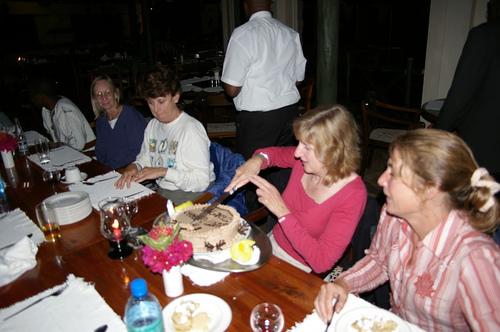What age group are these people in?
Concise answer only. 40s. How many people are at each table?
Answer briefly. 5. What color is the writing on the cake?
Quick response, please. Brown. What is the person holding?
Write a very short answer. Knife. Did they get married?
Short answer required. No. The girl on the right, what color is the school patch?
Quick response, please. Pink. Is this a birthday cake?
Give a very brief answer. Yes. What food is being served?
Quick response, please. Cake. Is this photo in color or black and white?
Be succinct. Color. What is the woman in red holding?
Give a very brief answer. Knife. How many people are at the table?
Give a very brief answer. 5. What holiday are these people celebrating in their house?
Write a very short answer. Birthday. Are the ladies on the right wearing the same color?
Give a very brief answer. Yes. What is she holding?
Be succinct. Knife. What does the lady right/front have in her hand?
Short answer required. Fork. How many girls are in the image?
Be succinct. 4. What is the lady in pink cutting?
Quick response, please. Cake. Are the people wearing name tags?
Short answer required. No. How many people are in the photo?
Keep it brief. 6. What color is the cake?
Concise answer only. Tan. 